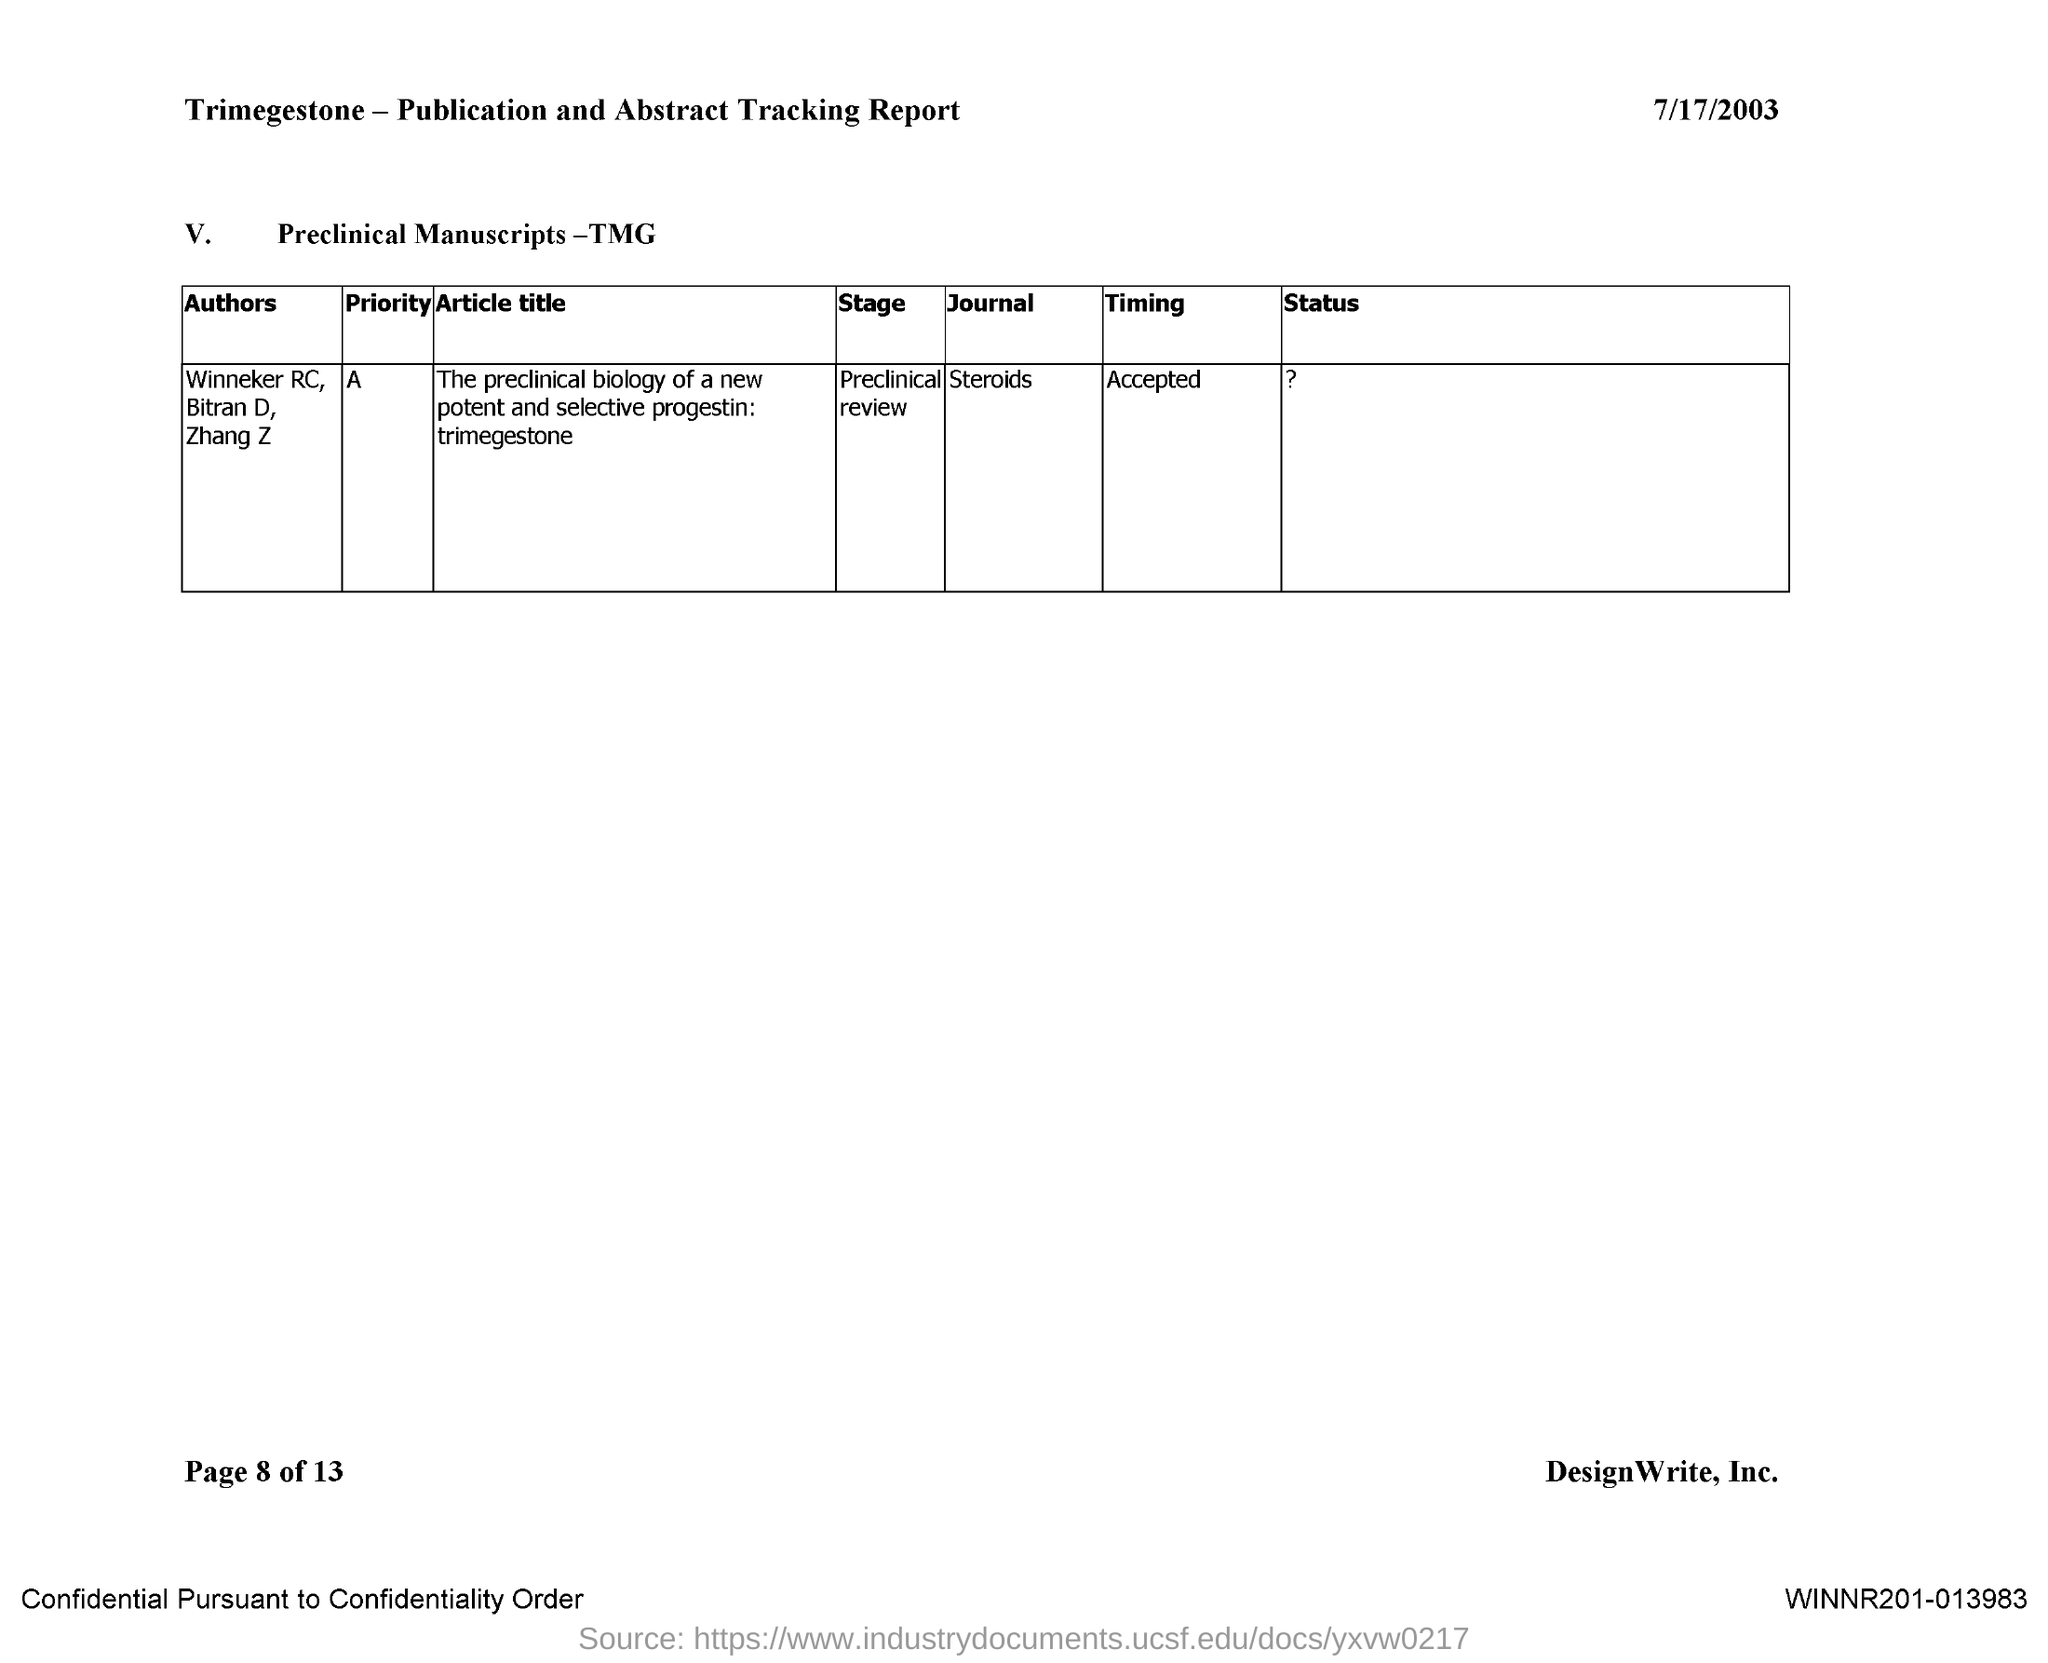Give some essential details in this illustration. The date mentioned in the document is July 17, 2003. The name of the journal is Steroids. The priority of the journal Steroids is represented by the alphabet A. 